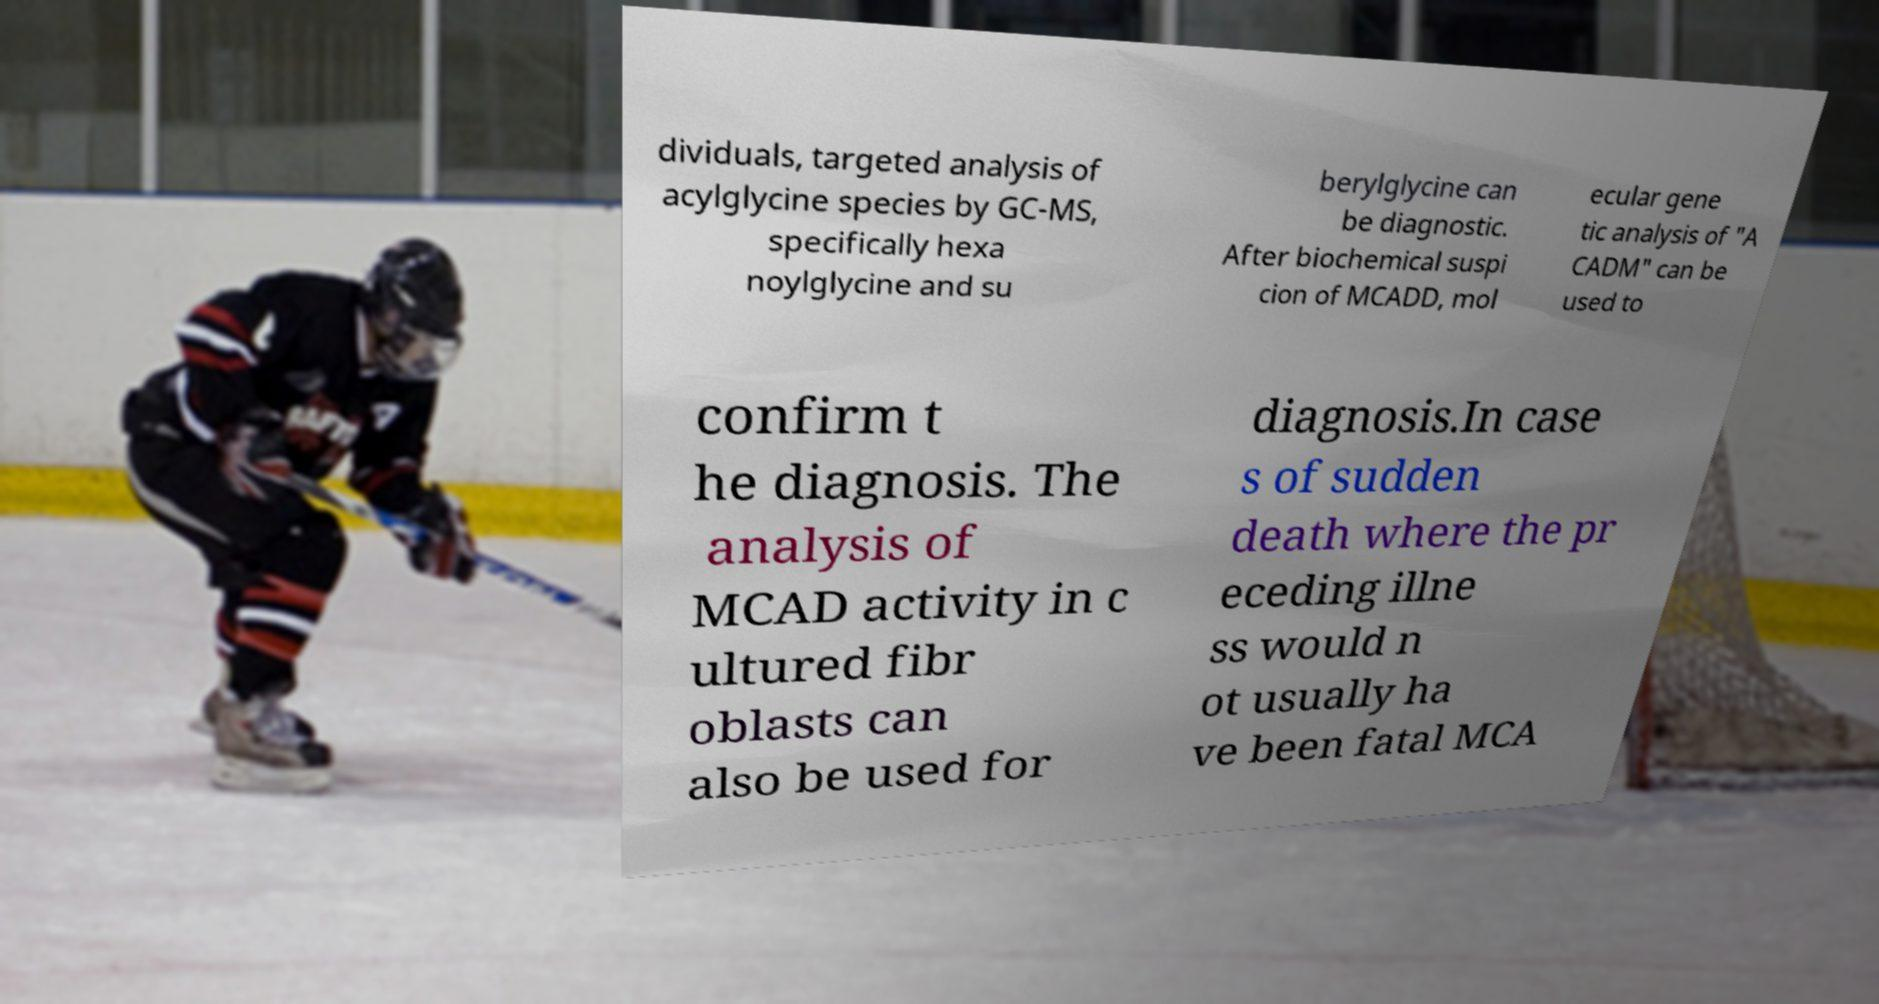For documentation purposes, I need the text within this image transcribed. Could you provide that? dividuals, targeted analysis of acylglycine species by GC-MS, specifically hexa noylglycine and su berylglycine can be diagnostic. After biochemical suspi cion of MCADD, mol ecular gene tic analysis of "A CADM" can be used to confirm t he diagnosis. The analysis of MCAD activity in c ultured fibr oblasts can also be used for diagnosis.In case s of sudden death where the pr eceding illne ss would n ot usually ha ve been fatal MCA 